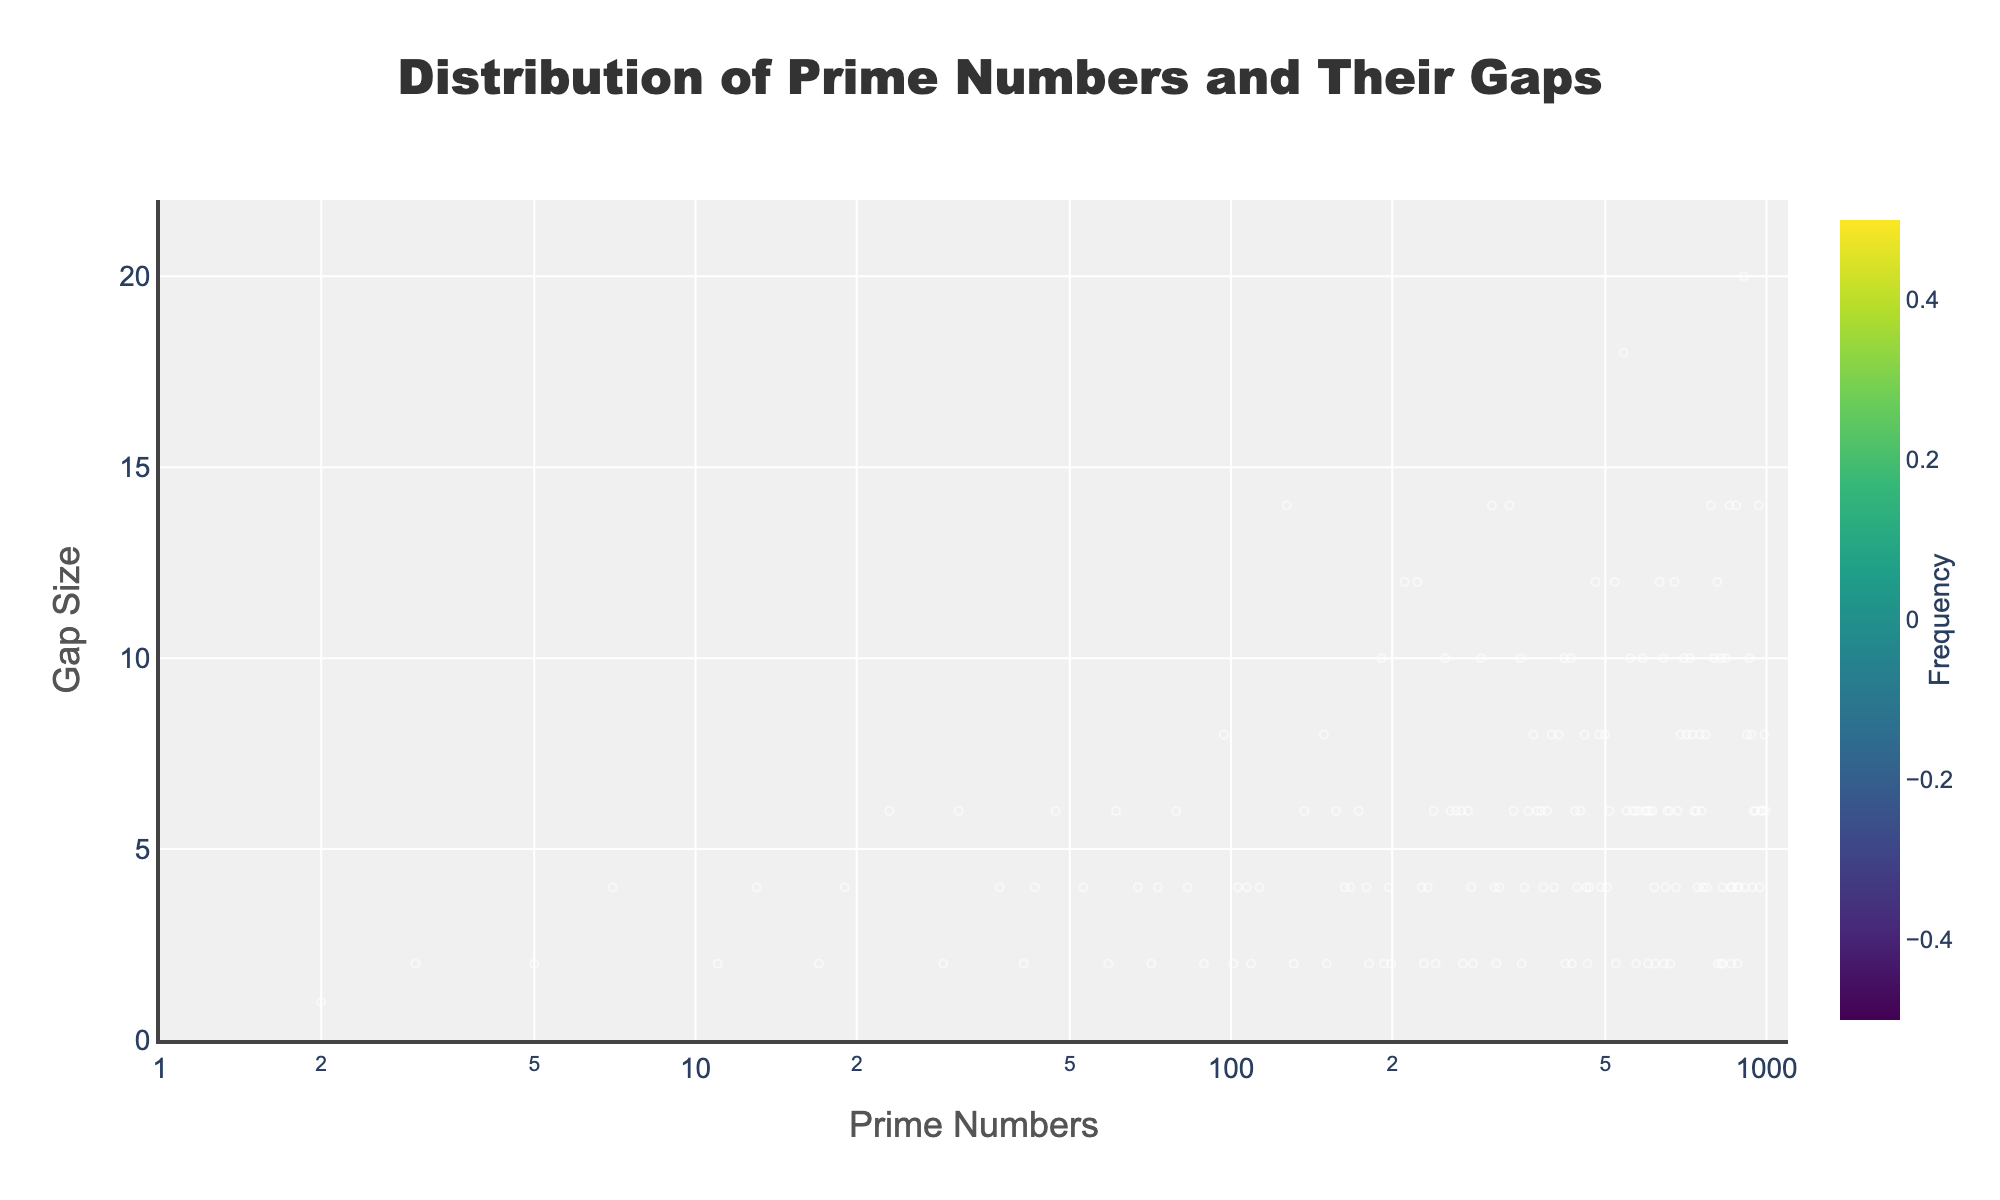What is the title of the figure? The title is displayed at the top of the figure, which provides a summary of what the figure represents. You can find it written in a larger, more prominent font.
Answer: Distribution of Prime Numbers and Their Gaps What data is shown on the x-axis? The x-axis typically represents a variable in a scatter plot. In this figure, the x-axis shows prime numbers.
Answer: Prime Numbers What data is shown on the y-axis? The y-axis typically represents another variable in a scatter plot. In this figure, the y-axis shows the gap size between prime numbers.
Answer: Gap Size How many bins are there along the x-axis? By examining the histogram part of the plot, you can count the divisions along the x-axis. The number of bins is specified programmatically but reflected visually. The plot description indicates 50 bins.
Answer: 50 What is the highest gap size observed? By checking the top of the y-axis, we can see the upper limit. In this case, it's slightly above 20.
Answer: About 20 What prime number range is most densely populated with gaps? By observing regions with the highest frequency color in the 2D histogram, the densely populated range can be determined. Clustering of markers also helps.
Answer: Around 2-500 Which gap size appears most frequently? The most frequent gap size can be identified using the colorbar and the areas of highest density in the 2D histogram.
Answer: 2 Do the smallest primes typically have larger gaps compared to larger primes? By examining the scatter plot distribution and the trend along both axes, it appears smaller primes (left of the plot) have smaller gaps than larger primes (right of the plot) where gaps increase slightly.
Answer: No What is the largest recorded prime number in the figure? By checking the far-right side of the x-axis, we locate the highest point. This is indicated around 10^6 but on the plot 997 is the maximum.
Answer: 997 How are the colors used in the plot, and what do they represent? Colors are used to show the frequency of data points within each bin. The colorbar indicates which colors correspond to higher or lower frequencies.
Answer: Frequencies of gaps among prime numbers 